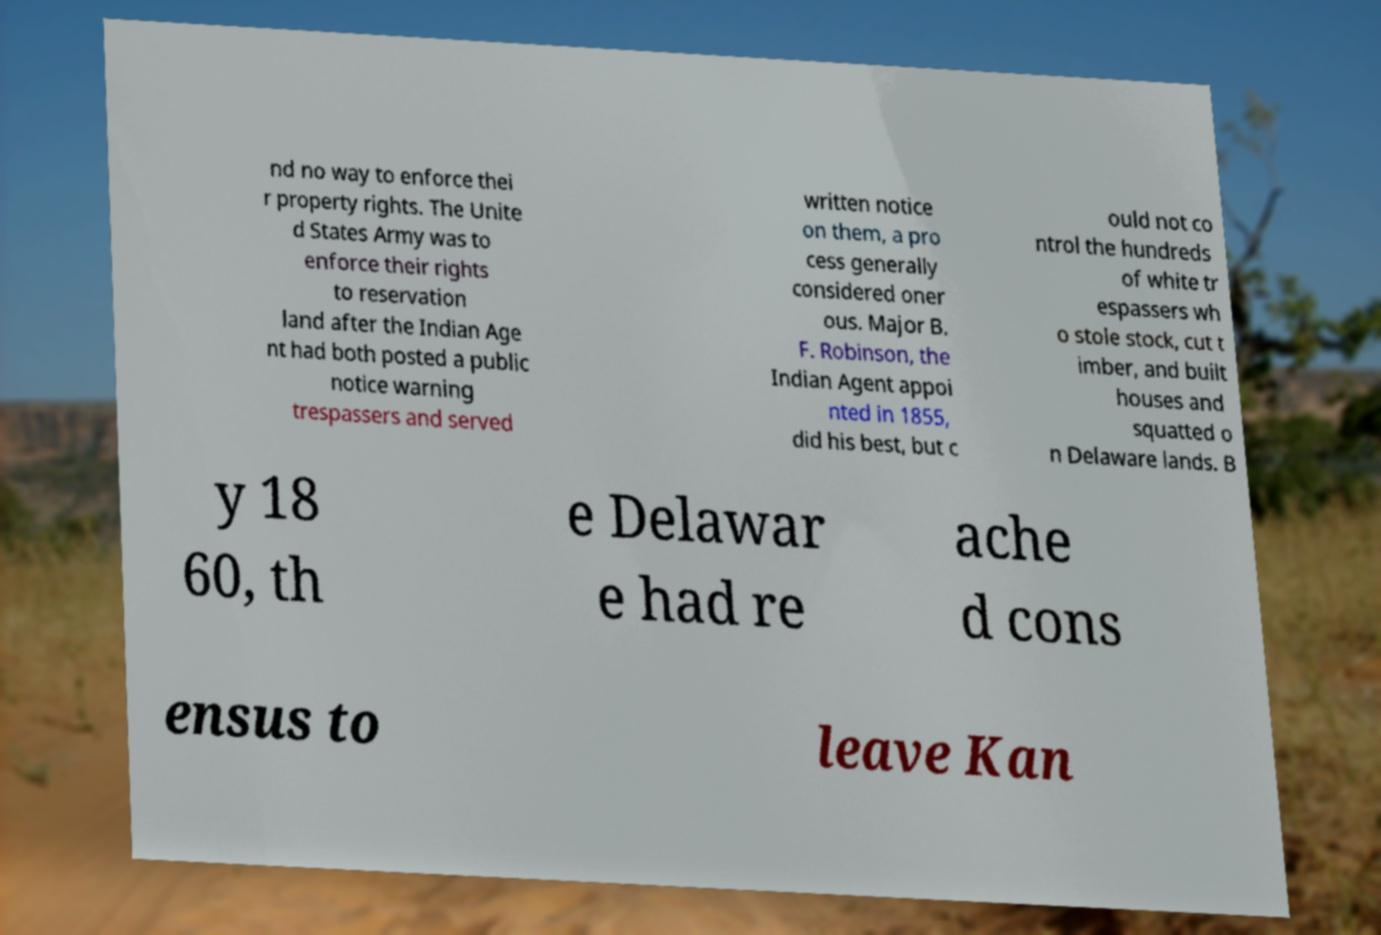Can you accurately transcribe the text from the provided image for me? nd no way to enforce thei r property rights. The Unite d States Army was to enforce their rights to reservation land after the Indian Age nt had both posted a public notice warning trespassers and served written notice on them, a pro cess generally considered oner ous. Major B. F. Robinson, the Indian Agent appoi nted in 1855, did his best, but c ould not co ntrol the hundreds of white tr espassers wh o stole stock, cut t imber, and built houses and squatted o n Delaware lands. B y 18 60, th e Delawar e had re ache d cons ensus to leave Kan 